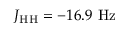Convert formula to latex. <formula><loc_0><loc_0><loc_500><loc_500>J _ { H H } = - 1 6 . 9 H z</formula> 